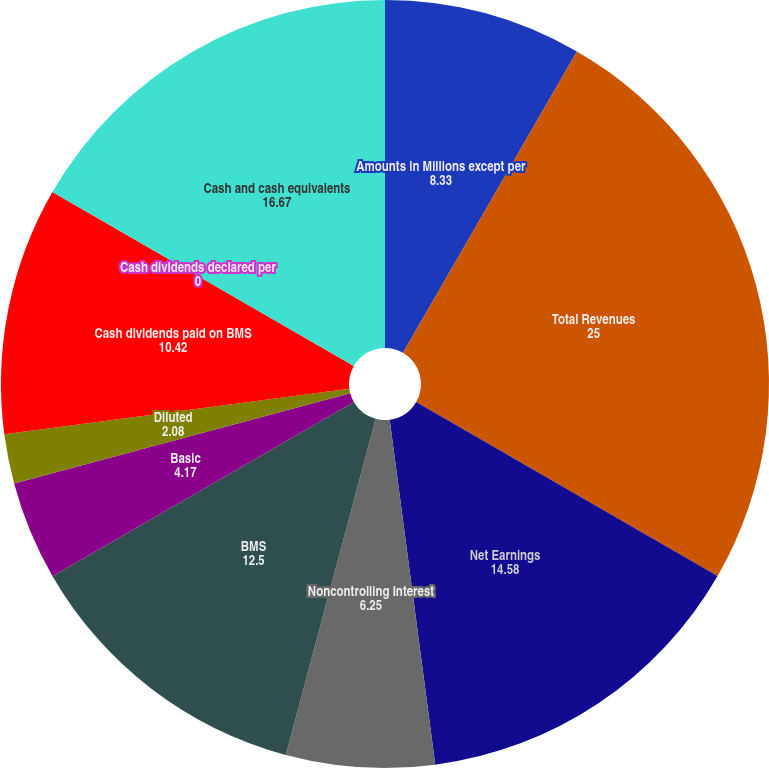Convert chart to OTSL. <chart><loc_0><loc_0><loc_500><loc_500><pie_chart><fcel>Amounts in Millions except per<fcel>Total Revenues<fcel>Net Earnings<fcel>Noncontrolling Interest<fcel>BMS<fcel>Basic<fcel>Diluted<fcel>Cash dividends paid on BMS<fcel>Cash dividends declared per<fcel>Cash and cash equivalents<nl><fcel>8.33%<fcel>25.0%<fcel>14.58%<fcel>6.25%<fcel>12.5%<fcel>4.17%<fcel>2.08%<fcel>10.42%<fcel>0.0%<fcel>16.67%<nl></chart> 